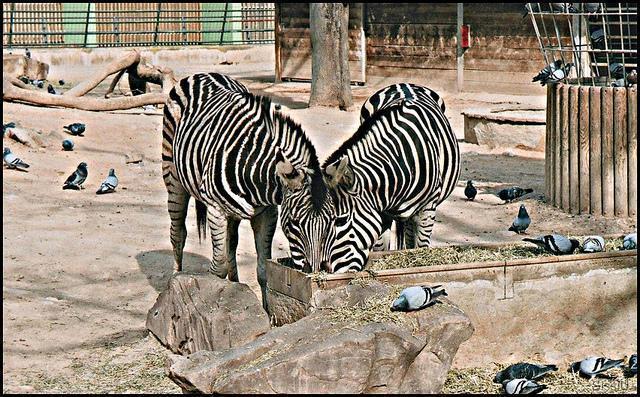How many zebras are eating hay from the trough?
From the following set of four choices, select the accurate answer to respond to the question.
Options: Two, three, one, four. Two. 